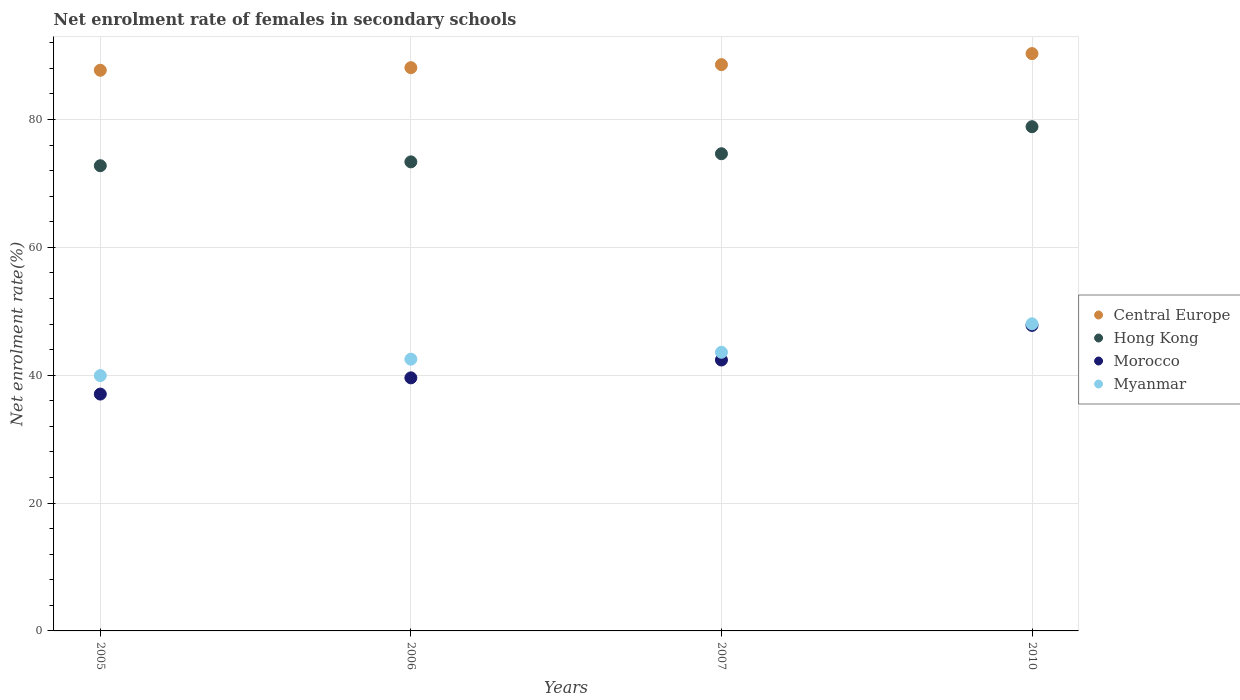How many different coloured dotlines are there?
Ensure brevity in your answer.  4. Is the number of dotlines equal to the number of legend labels?
Ensure brevity in your answer.  Yes. What is the net enrolment rate of females in secondary schools in Central Europe in 2007?
Make the answer very short. 88.57. Across all years, what is the maximum net enrolment rate of females in secondary schools in Morocco?
Give a very brief answer. 47.79. Across all years, what is the minimum net enrolment rate of females in secondary schools in Morocco?
Offer a terse response. 37.05. What is the total net enrolment rate of females in secondary schools in Myanmar in the graph?
Make the answer very short. 174.06. What is the difference between the net enrolment rate of females in secondary schools in Central Europe in 2006 and that in 2010?
Offer a terse response. -2.2. What is the difference between the net enrolment rate of females in secondary schools in Morocco in 2006 and the net enrolment rate of females in secondary schools in Myanmar in 2010?
Offer a very short reply. -8.45. What is the average net enrolment rate of females in secondary schools in Central Europe per year?
Offer a very short reply. 88.67. In the year 2006, what is the difference between the net enrolment rate of females in secondary schools in Myanmar and net enrolment rate of females in secondary schools in Central Europe?
Your response must be concise. -45.59. What is the ratio of the net enrolment rate of females in secondary schools in Morocco in 2005 to that in 2006?
Your answer should be compact. 0.94. Is the net enrolment rate of females in secondary schools in Morocco in 2005 less than that in 2010?
Ensure brevity in your answer.  Yes. What is the difference between the highest and the second highest net enrolment rate of females in secondary schools in Morocco?
Your response must be concise. 5.41. What is the difference between the highest and the lowest net enrolment rate of females in secondary schools in Hong Kong?
Provide a short and direct response. 6.1. In how many years, is the net enrolment rate of females in secondary schools in Hong Kong greater than the average net enrolment rate of females in secondary schools in Hong Kong taken over all years?
Give a very brief answer. 1. Is it the case that in every year, the sum of the net enrolment rate of females in secondary schools in Morocco and net enrolment rate of females in secondary schools in Central Europe  is greater than the sum of net enrolment rate of females in secondary schools in Hong Kong and net enrolment rate of females in secondary schools in Myanmar?
Provide a short and direct response. No. Is the net enrolment rate of females in secondary schools in Myanmar strictly greater than the net enrolment rate of females in secondary schools in Central Europe over the years?
Keep it short and to the point. No. How many dotlines are there?
Offer a very short reply. 4. How many years are there in the graph?
Your response must be concise. 4. What is the difference between two consecutive major ticks on the Y-axis?
Ensure brevity in your answer.  20. Does the graph contain grids?
Your response must be concise. Yes. Where does the legend appear in the graph?
Provide a succinct answer. Center right. How many legend labels are there?
Your answer should be very brief. 4. What is the title of the graph?
Ensure brevity in your answer.  Net enrolment rate of females in secondary schools. What is the label or title of the X-axis?
Give a very brief answer. Years. What is the label or title of the Y-axis?
Provide a succinct answer. Net enrolment rate(%). What is the Net enrolment rate(%) in Central Europe in 2005?
Make the answer very short. 87.69. What is the Net enrolment rate(%) in Hong Kong in 2005?
Your response must be concise. 72.76. What is the Net enrolment rate(%) of Morocco in 2005?
Your answer should be very brief. 37.05. What is the Net enrolment rate(%) of Myanmar in 2005?
Offer a terse response. 39.93. What is the Net enrolment rate(%) in Central Europe in 2006?
Your response must be concise. 88.1. What is the Net enrolment rate(%) in Hong Kong in 2006?
Ensure brevity in your answer.  73.37. What is the Net enrolment rate(%) of Morocco in 2006?
Offer a terse response. 39.58. What is the Net enrolment rate(%) in Myanmar in 2006?
Offer a very short reply. 42.51. What is the Net enrolment rate(%) in Central Europe in 2007?
Offer a very short reply. 88.57. What is the Net enrolment rate(%) in Hong Kong in 2007?
Offer a terse response. 74.64. What is the Net enrolment rate(%) in Morocco in 2007?
Give a very brief answer. 42.38. What is the Net enrolment rate(%) of Myanmar in 2007?
Ensure brevity in your answer.  43.58. What is the Net enrolment rate(%) in Central Europe in 2010?
Offer a very short reply. 90.3. What is the Net enrolment rate(%) of Hong Kong in 2010?
Offer a terse response. 78.86. What is the Net enrolment rate(%) of Morocco in 2010?
Give a very brief answer. 47.79. What is the Net enrolment rate(%) of Myanmar in 2010?
Provide a succinct answer. 48.03. Across all years, what is the maximum Net enrolment rate(%) in Central Europe?
Your response must be concise. 90.3. Across all years, what is the maximum Net enrolment rate(%) in Hong Kong?
Your answer should be compact. 78.86. Across all years, what is the maximum Net enrolment rate(%) of Morocco?
Make the answer very short. 47.79. Across all years, what is the maximum Net enrolment rate(%) of Myanmar?
Offer a terse response. 48.03. Across all years, what is the minimum Net enrolment rate(%) in Central Europe?
Your response must be concise. 87.69. Across all years, what is the minimum Net enrolment rate(%) in Hong Kong?
Make the answer very short. 72.76. Across all years, what is the minimum Net enrolment rate(%) in Morocco?
Make the answer very short. 37.05. Across all years, what is the minimum Net enrolment rate(%) of Myanmar?
Your answer should be compact. 39.93. What is the total Net enrolment rate(%) of Central Europe in the graph?
Offer a very short reply. 354.67. What is the total Net enrolment rate(%) in Hong Kong in the graph?
Offer a terse response. 299.63. What is the total Net enrolment rate(%) of Morocco in the graph?
Your answer should be very brief. 166.79. What is the total Net enrolment rate(%) of Myanmar in the graph?
Provide a succinct answer. 174.06. What is the difference between the Net enrolment rate(%) in Central Europe in 2005 and that in 2006?
Give a very brief answer. -0.41. What is the difference between the Net enrolment rate(%) in Hong Kong in 2005 and that in 2006?
Offer a terse response. -0.6. What is the difference between the Net enrolment rate(%) in Morocco in 2005 and that in 2006?
Make the answer very short. -2.54. What is the difference between the Net enrolment rate(%) of Myanmar in 2005 and that in 2006?
Your answer should be compact. -2.57. What is the difference between the Net enrolment rate(%) in Central Europe in 2005 and that in 2007?
Offer a terse response. -0.88. What is the difference between the Net enrolment rate(%) of Hong Kong in 2005 and that in 2007?
Make the answer very short. -1.88. What is the difference between the Net enrolment rate(%) of Morocco in 2005 and that in 2007?
Your response must be concise. -5.33. What is the difference between the Net enrolment rate(%) in Myanmar in 2005 and that in 2007?
Your answer should be compact. -3.65. What is the difference between the Net enrolment rate(%) of Central Europe in 2005 and that in 2010?
Provide a succinct answer. -2.61. What is the difference between the Net enrolment rate(%) of Hong Kong in 2005 and that in 2010?
Keep it short and to the point. -6.1. What is the difference between the Net enrolment rate(%) of Morocco in 2005 and that in 2010?
Offer a very short reply. -10.74. What is the difference between the Net enrolment rate(%) of Myanmar in 2005 and that in 2010?
Offer a terse response. -8.1. What is the difference between the Net enrolment rate(%) of Central Europe in 2006 and that in 2007?
Ensure brevity in your answer.  -0.47. What is the difference between the Net enrolment rate(%) in Hong Kong in 2006 and that in 2007?
Provide a short and direct response. -1.27. What is the difference between the Net enrolment rate(%) of Morocco in 2006 and that in 2007?
Your answer should be compact. -2.79. What is the difference between the Net enrolment rate(%) of Myanmar in 2006 and that in 2007?
Provide a succinct answer. -1.08. What is the difference between the Net enrolment rate(%) of Central Europe in 2006 and that in 2010?
Offer a very short reply. -2.2. What is the difference between the Net enrolment rate(%) of Hong Kong in 2006 and that in 2010?
Ensure brevity in your answer.  -5.5. What is the difference between the Net enrolment rate(%) in Morocco in 2006 and that in 2010?
Keep it short and to the point. -8.2. What is the difference between the Net enrolment rate(%) in Myanmar in 2006 and that in 2010?
Your answer should be compact. -5.53. What is the difference between the Net enrolment rate(%) of Central Europe in 2007 and that in 2010?
Provide a short and direct response. -1.73. What is the difference between the Net enrolment rate(%) of Hong Kong in 2007 and that in 2010?
Ensure brevity in your answer.  -4.23. What is the difference between the Net enrolment rate(%) in Morocco in 2007 and that in 2010?
Provide a short and direct response. -5.41. What is the difference between the Net enrolment rate(%) in Myanmar in 2007 and that in 2010?
Make the answer very short. -4.45. What is the difference between the Net enrolment rate(%) in Central Europe in 2005 and the Net enrolment rate(%) in Hong Kong in 2006?
Offer a terse response. 14.33. What is the difference between the Net enrolment rate(%) of Central Europe in 2005 and the Net enrolment rate(%) of Morocco in 2006?
Give a very brief answer. 48.11. What is the difference between the Net enrolment rate(%) of Central Europe in 2005 and the Net enrolment rate(%) of Myanmar in 2006?
Offer a very short reply. 45.19. What is the difference between the Net enrolment rate(%) of Hong Kong in 2005 and the Net enrolment rate(%) of Morocco in 2006?
Your answer should be very brief. 33.18. What is the difference between the Net enrolment rate(%) in Hong Kong in 2005 and the Net enrolment rate(%) in Myanmar in 2006?
Provide a succinct answer. 30.26. What is the difference between the Net enrolment rate(%) of Morocco in 2005 and the Net enrolment rate(%) of Myanmar in 2006?
Provide a succinct answer. -5.46. What is the difference between the Net enrolment rate(%) in Central Europe in 2005 and the Net enrolment rate(%) in Hong Kong in 2007?
Provide a succinct answer. 13.06. What is the difference between the Net enrolment rate(%) of Central Europe in 2005 and the Net enrolment rate(%) of Morocco in 2007?
Keep it short and to the point. 45.32. What is the difference between the Net enrolment rate(%) in Central Europe in 2005 and the Net enrolment rate(%) in Myanmar in 2007?
Offer a very short reply. 44.11. What is the difference between the Net enrolment rate(%) in Hong Kong in 2005 and the Net enrolment rate(%) in Morocco in 2007?
Your response must be concise. 30.38. What is the difference between the Net enrolment rate(%) of Hong Kong in 2005 and the Net enrolment rate(%) of Myanmar in 2007?
Offer a terse response. 29.18. What is the difference between the Net enrolment rate(%) in Morocco in 2005 and the Net enrolment rate(%) in Myanmar in 2007?
Provide a succinct answer. -6.54. What is the difference between the Net enrolment rate(%) in Central Europe in 2005 and the Net enrolment rate(%) in Hong Kong in 2010?
Your response must be concise. 8.83. What is the difference between the Net enrolment rate(%) in Central Europe in 2005 and the Net enrolment rate(%) in Morocco in 2010?
Ensure brevity in your answer.  39.91. What is the difference between the Net enrolment rate(%) of Central Europe in 2005 and the Net enrolment rate(%) of Myanmar in 2010?
Ensure brevity in your answer.  39.66. What is the difference between the Net enrolment rate(%) in Hong Kong in 2005 and the Net enrolment rate(%) in Morocco in 2010?
Offer a very short reply. 24.98. What is the difference between the Net enrolment rate(%) in Hong Kong in 2005 and the Net enrolment rate(%) in Myanmar in 2010?
Give a very brief answer. 24.73. What is the difference between the Net enrolment rate(%) in Morocco in 2005 and the Net enrolment rate(%) in Myanmar in 2010?
Make the answer very short. -10.99. What is the difference between the Net enrolment rate(%) of Central Europe in 2006 and the Net enrolment rate(%) of Hong Kong in 2007?
Provide a short and direct response. 13.46. What is the difference between the Net enrolment rate(%) in Central Europe in 2006 and the Net enrolment rate(%) in Morocco in 2007?
Make the answer very short. 45.72. What is the difference between the Net enrolment rate(%) of Central Europe in 2006 and the Net enrolment rate(%) of Myanmar in 2007?
Your answer should be very brief. 44.52. What is the difference between the Net enrolment rate(%) of Hong Kong in 2006 and the Net enrolment rate(%) of Morocco in 2007?
Ensure brevity in your answer.  30.99. What is the difference between the Net enrolment rate(%) in Hong Kong in 2006 and the Net enrolment rate(%) in Myanmar in 2007?
Provide a succinct answer. 29.78. What is the difference between the Net enrolment rate(%) of Morocco in 2006 and the Net enrolment rate(%) of Myanmar in 2007?
Your answer should be compact. -4. What is the difference between the Net enrolment rate(%) of Central Europe in 2006 and the Net enrolment rate(%) of Hong Kong in 2010?
Your answer should be compact. 9.24. What is the difference between the Net enrolment rate(%) of Central Europe in 2006 and the Net enrolment rate(%) of Morocco in 2010?
Provide a short and direct response. 40.31. What is the difference between the Net enrolment rate(%) of Central Europe in 2006 and the Net enrolment rate(%) of Myanmar in 2010?
Keep it short and to the point. 40.07. What is the difference between the Net enrolment rate(%) of Hong Kong in 2006 and the Net enrolment rate(%) of Morocco in 2010?
Make the answer very short. 25.58. What is the difference between the Net enrolment rate(%) in Hong Kong in 2006 and the Net enrolment rate(%) in Myanmar in 2010?
Your response must be concise. 25.33. What is the difference between the Net enrolment rate(%) in Morocco in 2006 and the Net enrolment rate(%) in Myanmar in 2010?
Your answer should be very brief. -8.45. What is the difference between the Net enrolment rate(%) in Central Europe in 2007 and the Net enrolment rate(%) in Hong Kong in 2010?
Offer a very short reply. 9.71. What is the difference between the Net enrolment rate(%) of Central Europe in 2007 and the Net enrolment rate(%) of Morocco in 2010?
Offer a very short reply. 40.79. What is the difference between the Net enrolment rate(%) of Central Europe in 2007 and the Net enrolment rate(%) of Myanmar in 2010?
Ensure brevity in your answer.  40.54. What is the difference between the Net enrolment rate(%) of Hong Kong in 2007 and the Net enrolment rate(%) of Morocco in 2010?
Make the answer very short. 26.85. What is the difference between the Net enrolment rate(%) in Hong Kong in 2007 and the Net enrolment rate(%) in Myanmar in 2010?
Keep it short and to the point. 26.6. What is the difference between the Net enrolment rate(%) in Morocco in 2007 and the Net enrolment rate(%) in Myanmar in 2010?
Your answer should be compact. -5.66. What is the average Net enrolment rate(%) in Central Europe per year?
Your response must be concise. 88.67. What is the average Net enrolment rate(%) of Hong Kong per year?
Provide a short and direct response. 74.91. What is the average Net enrolment rate(%) in Morocco per year?
Offer a very short reply. 41.7. What is the average Net enrolment rate(%) in Myanmar per year?
Give a very brief answer. 43.51. In the year 2005, what is the difference between the Net enrolment rate(%) in Central Europe and Net enrolment rate(%) in Hong Kong?
Your response must be concise. 14.93. In the year 2005, what is the difference between the Net enrolment rate(%) in Central Europe and Net enrolment rate(%) in Morocco?
Your response must be concise. 50.65. In the year 2005, what is the difference between the Net enrolment rate(%) in Central Europe and Net enrolment rate(%) in Myanmar?
Provide a succinct answer. 47.76. In the year 2005, what is the difference between the Net enrolment rate(%) in Hong Kong and Net enrolment rate(%) in Morocco?
Offer a terse response. 35.72. In the year 2005, what is the difference between the Net enrolment rate(%) in Hong Kong and Net enrolment rate(%) in Myanmar?
Your response must be concise. 32.83. In the year 2005, what is the difference between the Net enrolment rate(%) in Morocco and Net enrolment rate(%) in Myanmar?
Offer a terse response. -2.89. In the year 2006, what is the difference between the Net enrolment rate(%) in Central Europe and Net enrolment rate(%) in Hong Kong?
Your answer should be compact. 14.73. In the year 2006, what is the difference between the Net enrolment rate(%) in Central Europe and Net enrolment rate(%) in Morocco?
Offer a terse response. 48.52. In the year 2006, what is the difference between the Net enrolment rate(%) of Central Europe and Net enrolment rate(%) of Myanmar?
Keep it short and to the point. 45.59. In the year 2006, what is the difference between the Net enrolment rate(%) in Hong Kong and Net enrolment rate(%) in Morocco?
Make the answer very short. 33.78. In the year 2006, what is the difference between the Net enrolment rate(%) of Hong Kong and Net enrolment rate(%) of Myanmar?
Offer a very short reply. 30.86. In the year 2006, what is the difference between the Net enrolment rate(%) in Morocco and Net enrolment rate(%) in Myanmar?
Offer a very short reply. -2.92. In the year 2007, what is the difference between the Net enrolment rate(%) of Central Europe and Net enrolment rate(%) of Hong Kong?
Keep it short and to the point. 13.94. In the year 2007, what is the difference between the Net enrolment rate(%) in Central Europe and Net enrolment rate(%) in Morocco?
Provide a succinct answer. 46.2. In the year 2007, what is the difference between the Net enrolment rate(%) in Central Europe and Net enrolment rate(%) in Myanmar?
Offer a terse response. 44.99. In the year 2007, what is the difference between the Net enrolment rate(%) in Hong Kong and Net enrolment rate(%) in Morocco?
Offer a terse response. 32.26. In the year 2007, what is the difference between the Net enrolment rate(%) of Hong Kong and Net enrolment rate(%) of Myanmar?
Your answer should be very brief. 31.05. In the year 2007, what is the difference between the Net enrolment rate(%) in Morocco and Net enrolment rate(%) in Myanmar?
Make the answer very short. -1.21. In the year 2010, what is the difference between the Net enrolment rate(%) of Central Europe and Net enrolment rate(%) of Hong Kong?
Give a very brief answer. 11.44. In the year 2010, what is the difference between the Net enrolment rate(%) in Central Europe and Net enrolment rate(%) in Morocco?
Offer a terse response. 42.51. In the year 2010, what is the difference between the Net enrolment rate(%) in Central Europe and Net enrolment rate(%) in Myanmar?
Offer a very short reply. 42.27. In the year 2010, what is the difference between the Net enrolment rate(%) of Hong Kong and Net enrolment rate(%) of Morocco?
Provide a succinct answer. 31.08. In the year 2010, what is the difference between the Net enrolment rate(%) in Hong Kong and Net enrolment rate(%) in Myanmar?
Ensure brevity in your answer.  30.83. In the year 2010, what is the difference between the Net enrolment rate(%) in Morocco and Net enrolment rate(%) in Myanmar?
Ensure brevity in your answer.  -0.25. What is the ratio of the Net enrolment rate(%) in Central Europe in 2005 to that in 2006?
Provide a short and direct response. 1. What is the ratio of the Net enrolment rate(%) in Hong Kong in 2005 to that in 2006?
Give a very brief answer. 0.99. What is the ratio of the Net enrolment rate(%) of Morocco in 2005 to that in 2006?
Give a very brief answer. 0.94. What is the ratio of the Net enrolment rate(%) of Myanmar in 2005 to that in 2006?
Make the answer very short. 0.94. What is the ratio of the Net enrolment rate(%) of Hong Kong in 2005 to that in 2007?
Offer a terse response. 0.97. What is the ratio of the Net enrolment rate(%) in Morocco in 2005 to that in 2007?
Your answer should be compact. 0.87. What is the ratio of the Net enrolment rate(%) in Myanmar in 2005 to that in 2007?
Provide a short and direct response. 0.92. What is the ratio of the Net enrolment rate(%) of Central Europe in 2005 to that in 2010?
Provide a short and direct response. 0.97. What is the ratio of the Net enrolment rate(%) in Hong Kong in 2005 to that in 2010?
Offer a terse response. 0.92. What is the ratio of the Net enrolment rate(%) of Morocco in 2005 to that in 2010?
Ensure brevity in your answer.  0.78. What is the ratio of the Net enrolment rate(%) in Myanmar in 2005 to that in 2010?
Your answer should be compact. 0.83. What is the ratio of the Net enrolment rate(%) in Hong Kong in 2006 to that in 2007?
Your response must be concise. 0.98. What is the ratio of the Net enrolment rate(%) in Morocco in 2006 to that in 2007?
Your response must be concise. 0.93. What is the ratio of the Net enrolment rate(%) in Myanmar in 2006 to that in 2007?
Offer a terse response. 0.98. What is the ratio of the Net enrolment rate(%) of Central Europe in 2006 to that in 2010?
Your response must be concise. 0.98. What is the ratio of the Net enrolment rate(%) of Hong Kong in 2006 to that in 2010?
Offer a terse response. 0.93. What is the ratio of the Net enrolment rate(%) in Morocco in 2006 to that in 2010?
Your response must be concise. 0.83. What is the ratio of the Net enrolment rate(%) of Myanmar in 2006 to that in 2010?
Offer a very short reply. 0.88. What is the ratio of the Net enrolment rate(%) in Central Europe in 2007 to that in 2010?
Your response must be concise. 0.98. What is the ratio of the Net enrolment rate(%) in Hong Kong in 2007 to that in 2010?
Give a very brief answer. 0.95. What is the ratio of the Net enrolment rate(%) in Morocco in 2007 to that in 2010?
Make the answer very short. 0.89. What is the ratio of the Net enrolment rate(%) in Myanmar in 2007 to that in 2010?
Make the answer very short. 0.91. What is the difference between the highest and the second highest Net enrolment rate(%) in Central Europe?
Your answer should be compact. 1.73. What is the difference between the highest and the second highest Net enrolment rate(%) in Hong Kong?
Your answer should be compact. 4.23. What is the difference between the highest and the second highest Net enrolment rate(%) of Morocco?
Offer a very short reply. 5.41. What is the difference between the highest and the second highest Net enrolment rate(%) in Myanmar?
Make the answer very short. 4.45. What is the difference between the highest and the lowest Net enrolment rate(%) in Central Europe?
Provide a succinct answer. 2.61. What is the difference between the highest and the lowest Net enrolment rate(%) of Hong Kong?
Your response must be concise. 6.1. What is the difference between the highest and the lowest Net enrolment rate(%) in Morocco?
Offer a terse response. 10.74. What is the difference between the highest and the lowest Net enrolment rate(%) in Myanmar?
Keep it short and to the point. 8.1. 